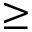Convert formula to latex. <formula><loc_0><loc_0><loc_500><loc_500>\geq</formula> 